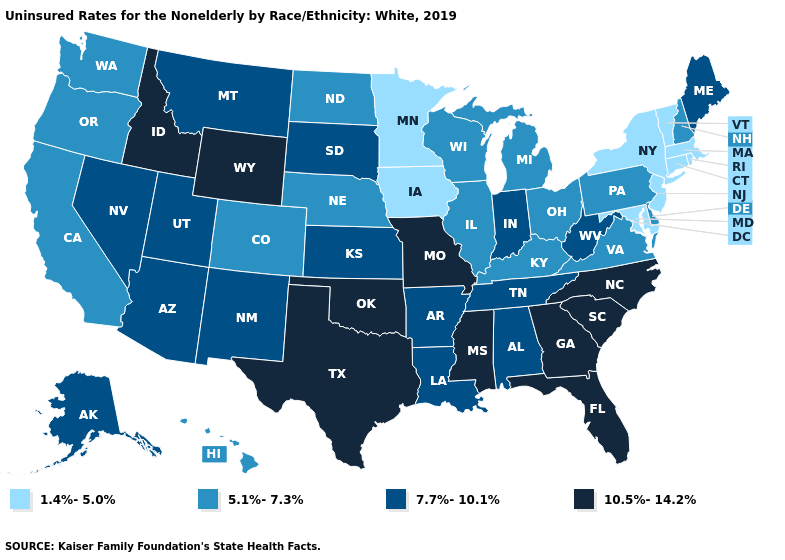Name the states that have a value in the range 7.7%-10.1%?
Answer briefly. Alabama, Alaska, Arizona, Arkansas, Indiana, Kansas, Louisiana, Maine, Montana, Nevada, New Mexico, South Dakota, Tennessee, Utah, West Virginia. What is the value of Indiana?
Keep it brief. 7.7%-10.1%. Name the states that have a value in the range 10.5%-14.2%?
Short answer required. Florida, Georgia, Idaho, Mississippi, Missouri, North Carolina, Oklahoma, South Carolina, Texas, Wyoming. What is the value of Kansas?
Answer briefly. 7.7%-10.1%. Does the first symbol in the legend represent the smallest category?
Write a very short answer. Yes. What is the highest value in the West ?
Write a very short answer. 10.5%-14.2%. Which states have the highest value in the USA?
Be succinct. Florida, Georgia, Idaho, Mississippi, Missouri, North Carolina, Oklahoma, South Carolina, Texas, Wyoming. What is the lowest value in states that border California?
Concise answer only. 5.1%-7.3%. Name the states that have a value in the range 5.1%-7.3%?
Concise answer only. California, Colorado, Delaware, Hawaii, Illinois, Kentucky, Michigan, Nebraska, New Hampshire, North Dakota, Ohio, Oregon, Pennsylvania, Virginia, Washington, Wisconsin. Name the states that have a value in the range 1.4%-5.0%?
Give a very brief answer. Connecticut, Iowa, Maryland, Massachusetts, Minnesota, New Jersey, New York, Rhode Island, Vermont. Does Wyoming have the highest value in the West?
Concise answer only. Yes. Does Pennsylvania have the highest value in the USA?
Concise answer only. No. Does North Carolina have the highest value in the USA?
Short answer required. Yes. Does Oregon have the same value as New Jersey?
Concise answer only. No. What is the lowest value in the Northeast?
Answer briefly. 1.4%-5.0%. 